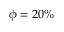<formula> <loc_0><loc_0><loc_500><loc_500>\phi = 2 0 \%</formula> 